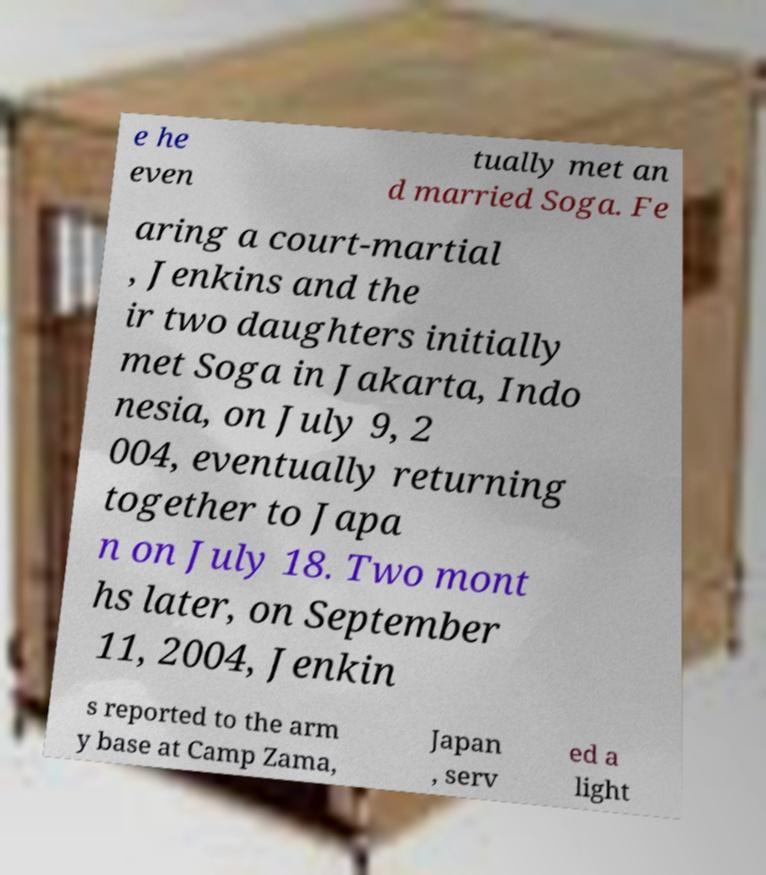Could you assist in decoding the text presented in this image and type it out clearly? e he even tually met an d married Soga. Fe aring a court-martial , Jenkins and the ir two daughters initially met Soga in Jakarta, Indo nesia, on July 9, 2 004, eventually returning together to Japa n on July 18. Two mont hs later, on September 11, 2004, Jenkin s reported to the arm y base at Camp Zama, Japan , serv ed a light 